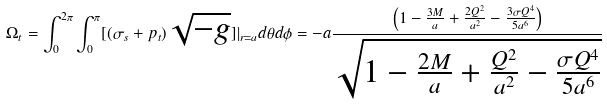<formula> <loc_0><loc_0><loc_500><loc_500>\Omega _ { t } = \int _ { 0 } ^ { 2 \pi } \int _ { 0 } ^ { \pi } [ ( \sigma _ { s } + p _ { t } ) \sqrt { - g } ] | _ { r = a } d { \theta } d { \phi } = - a \frac { \left ( 1 - \frac { 3 M } { a } + \frac { 2 Q ^ { 2 } } { a ^ { 2 } } - \frac { 3 \sigma Q ^ { 4 } } { 5 a ^ { 6 } } \right ) } { \sqrt { 1 - \frac { 2 M } { a } + \frac { Q ^ { 2 } } { a ^ { 2 } } - \frac { \sigma Q ^ { 4 } } { 5 a ^ { 6 } } } }</formula> 